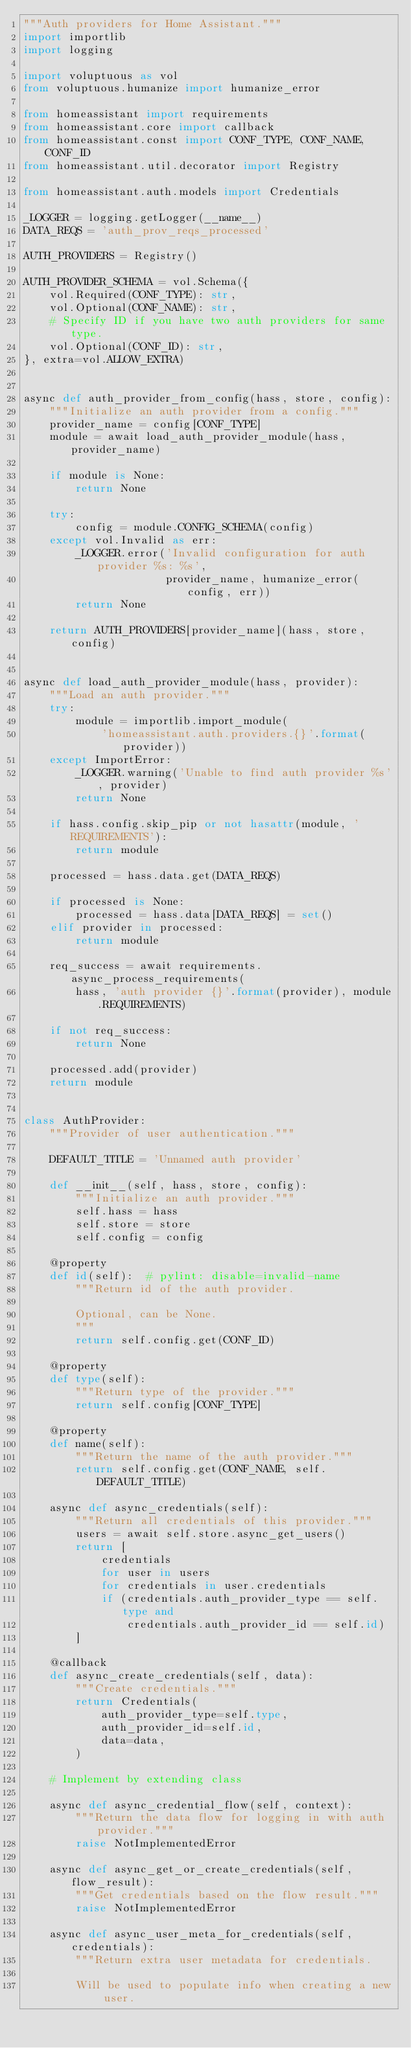<code> <loc_0><loc_0><loc_500><loc_500><_Python_>"""Auth providers for Home Assistant."""
import importlib
import logging

import voluptuous as vol
from voluptuous.humanize import humanize_error

from homeassistant import requirements
from homeassistant.core import callback
from homeassistant.const import CONF_TYPE, CONF_NAME, CONF_ID
from homeassistant.util.decorator import Registry

from homeassistant.auth.models import Credentials

_LOGGER = logging.getLogger(__name__)
DATA_REQS = 'auth_prov_reqs_processed'

AUTH_PROVIDERS = Registry()

AUTH_PROVIDER_SCHEMA = vol.Schema({
    vol.Required(CONF_TYPE): str,
    vol.Optional(CONF_NAME): str,
    # Specify ID if you have two auth providers for same type.
    vol.Optional(CONF_ID): str,
}, extra=vol.ALLOW_EXTRA)


async def auth_provider_from_config(hass, store, config):
    """Initialize an auth provider from a config."""
    provider_name = config[CONF_TYPE]
    module = await load_auth_provider_module(hass, provider_name)

    if module is None:
        return None

    try:
        config = module.CONFIG_SCHEMA(config)
    except vol.Invalid as err:
        _LOGGER.error('Invalid configuration for auth provider %s: %s',
                      provider_name, humanize_error(config, err))
        return None

    return AUTH_PROVIDERS[provider_name](hass, store, config)


async def load_auth_provider_module(hass, provider):
    """Load an auth provider."""
    try:
        module = importlib.import_module(
            'homeassistant.auth.providers.{}'.format(provider))
    except ImportError:
        _LOGGER.warning('Unable to find auth provider %s', provider)
        return None

    if hass.config.skip_pip or not hasattr(module, 'REQUIREMENTS'):
        return module

    processed = hass.data.get(DATA_REQS)

    if processed is None:
        processed = hass.data[DATA_REQS] = set()
    elif provider in processed:
        return module

    req_success = await requirements.async_process_requirements(
        hass, 'auth provider {}'.format(provider), module.REQUIREMENTS)

    if not req_success:
        return None

    processed.add(provider)
    return module


class AuthProvider:
    """Provider of user authentication."""

    DEFAULT_TITLE = 'Unnamed auth provider'

    def __init__(self, hass, store, config):
        """Initialize an auth provider."""
        self.hass = hass
        self.store = store
        self.config = config

    @property
    def id(self):  # pylint: disable=invalid-name
        """Return id of the auth provider.

        Optional, can be None.
        """
        return self.config.get(CONF_ID)

    @property
    def type(self):
        """Return type of the provider."""
        return self.config[CONF_TYPE]

    @property
    def name(self):
        """Return the name of the auth provider."""
        return self.config.get(CONF_NAME, self.DEFAULT_TITLE)

    async def async_credentials(self):
        """Return all credentials of this provider."""
        users = await self.store.async_get_users()
        return [
            credentials
            for user in users
            for credentials in user.credentials
            if (credentials.auth_provider_type == self.type and
                credentials.auth_provider_id == self.id)
        ]

    @callback
    def async_create_credentials(self, data):
        """Create credentials."""
        return Credentials(
            auth_provider_type=self.type,
            auth_provider_id=self.id,
            data=data,
        )

    # Implement by extending class

    async def async_credential_flow(self, context):
        """Return the data flow for logging in with auth provider."""
        raise NotImplementedError

    async def async_get_or_create_credentials(self, flow_result):
        """Get credentials based on the flow result."""
        raise NotImplementedError

    async def async_user_meta_for_credentials(self, credentials):
        """Return extra user metadata for credentials.

        Will be used to populate info when creating a new user.
</code> 